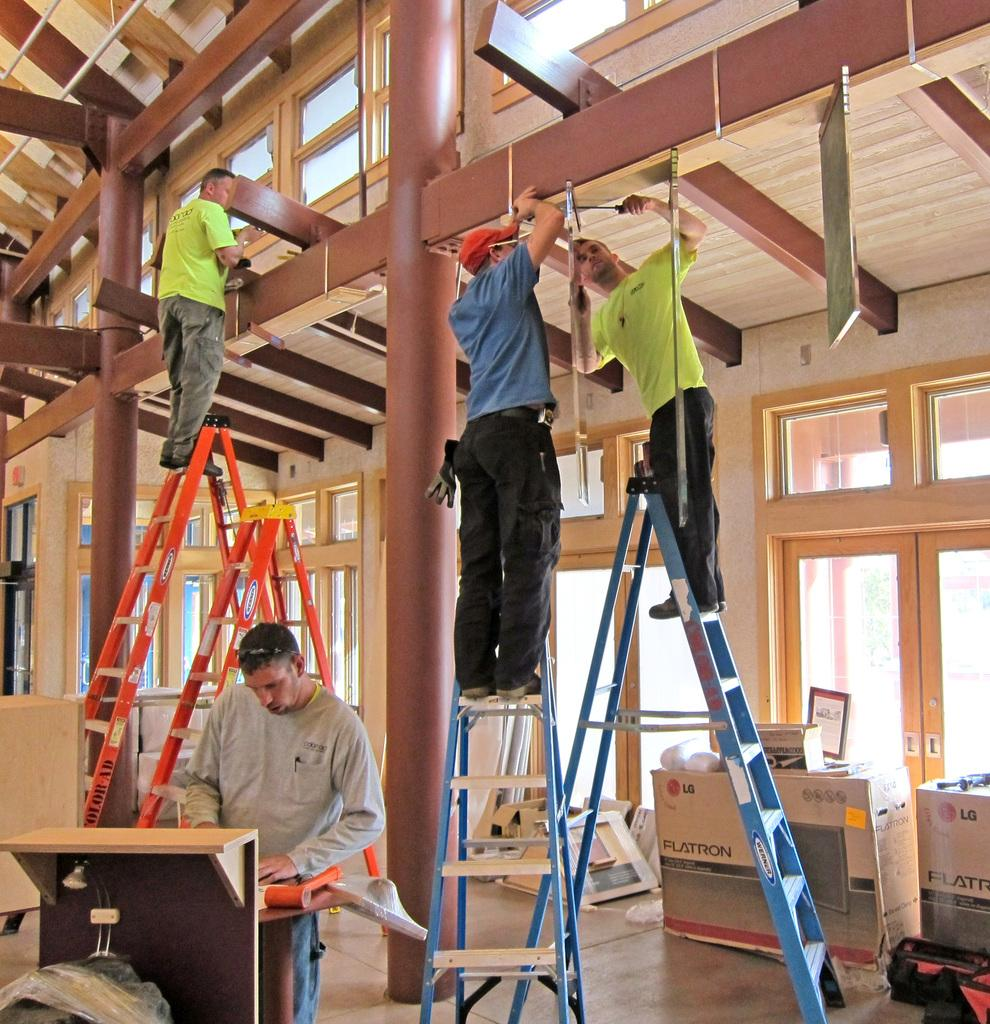How many people are present in the image? There are people in the image, but the exact number cannot be determined from the provided facts. What type of furniture is visible in the image? There is a table in the image. What objects are used for climbing in the image? There are ladders in the image. What part of the room can be seen in the image? The floor is visible in the image. What type of containers are present in the image? There are carton boxes in the image. What type of architectural feature is present in the image? There are doors in the image. What type of vertical structures are present in the image? There are poles in the image. What part of the building can be seen in the image? The roof is visible in the image. What type of bedroom can be seen in the image? There is no mention of a bedroom in the provided facts, so it cannot be determined from the image. 